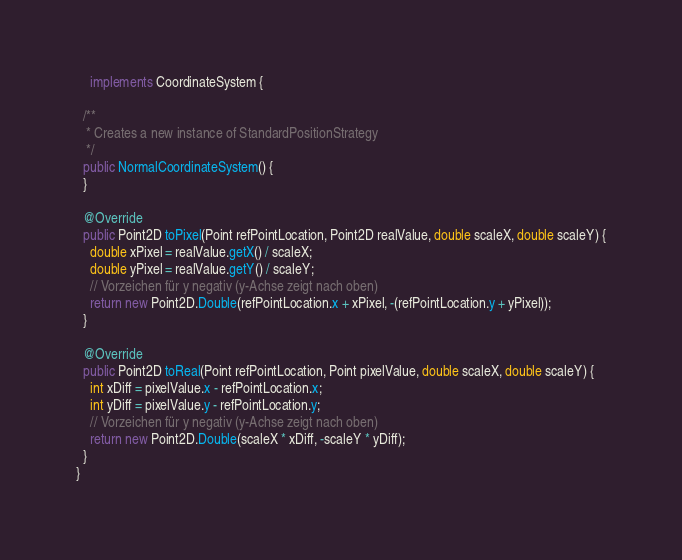Convert code to text. <code><loc_0><loc_0><loc_500><loc_500><_Java_>    implements CoordinateSystem {

  /**
   * Creates a new instance of StandardPositionStrategy
   */
  public NormalCoordinateSystem() {
  }

  @Override
  public Point2D toPixel(Point refPointLocation, Point2D realValue, double scaleX, double scaleY) {
    double xPixel = realValue.getX() / scaleX;
    double yPixel = realValue.getY() / scaleY;
    // Vorzeichen für y negativ (y-Achse zeigt nach oben)
    return new Point2D.Double(refPointLocation.x + xPixel, -(refPointLocation.y + yPixel));
  }

  @Override
  public Point2D toReal(Point refPointLocation, Point pixelValue, double scaleX, double scaleY) {
    int xDiff = pixelValue.x - refPointLocation.x;
    int yDiff = pixelValue.y - refPointLocation.y;
    // Vorzeichen für y negativ (y-Achse zeigt nach oben)
    return new Point2D.Double(scaleX * xDiff, -scaleY * yDiff);
  }
}
</code> 